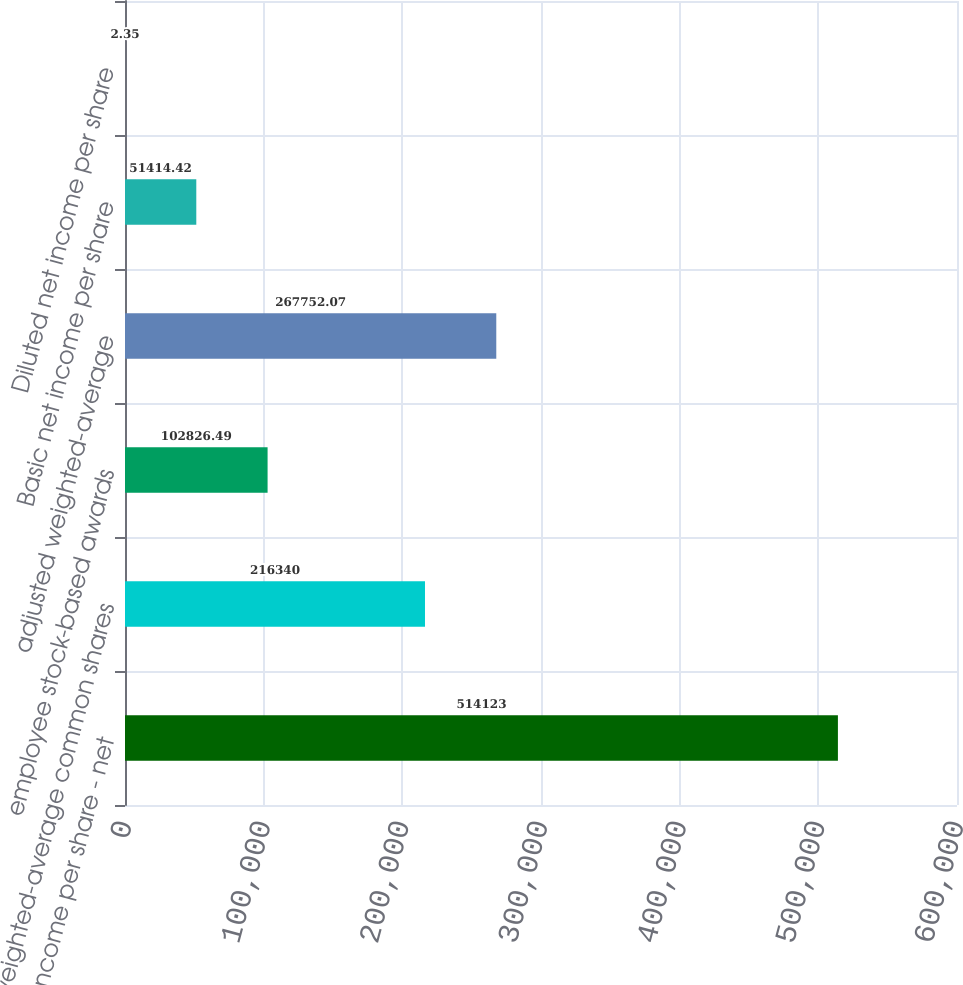Convert chart to OTSL. <chart><loc_0><loc_0><loc_500><loc_500><bar_chart><fcel>net income per share - net<fcel>weighted-average common shares<fcel>employee stock-based awards<fcel>adjusted weighted-average<fcel>Basic net income per share<fcel>Diluted net income per share<nl><fcel>514123<fcel>216340<fcel>102826<fcel>267752<fcel>51414.4<fcel>2.35<nl></chart> 